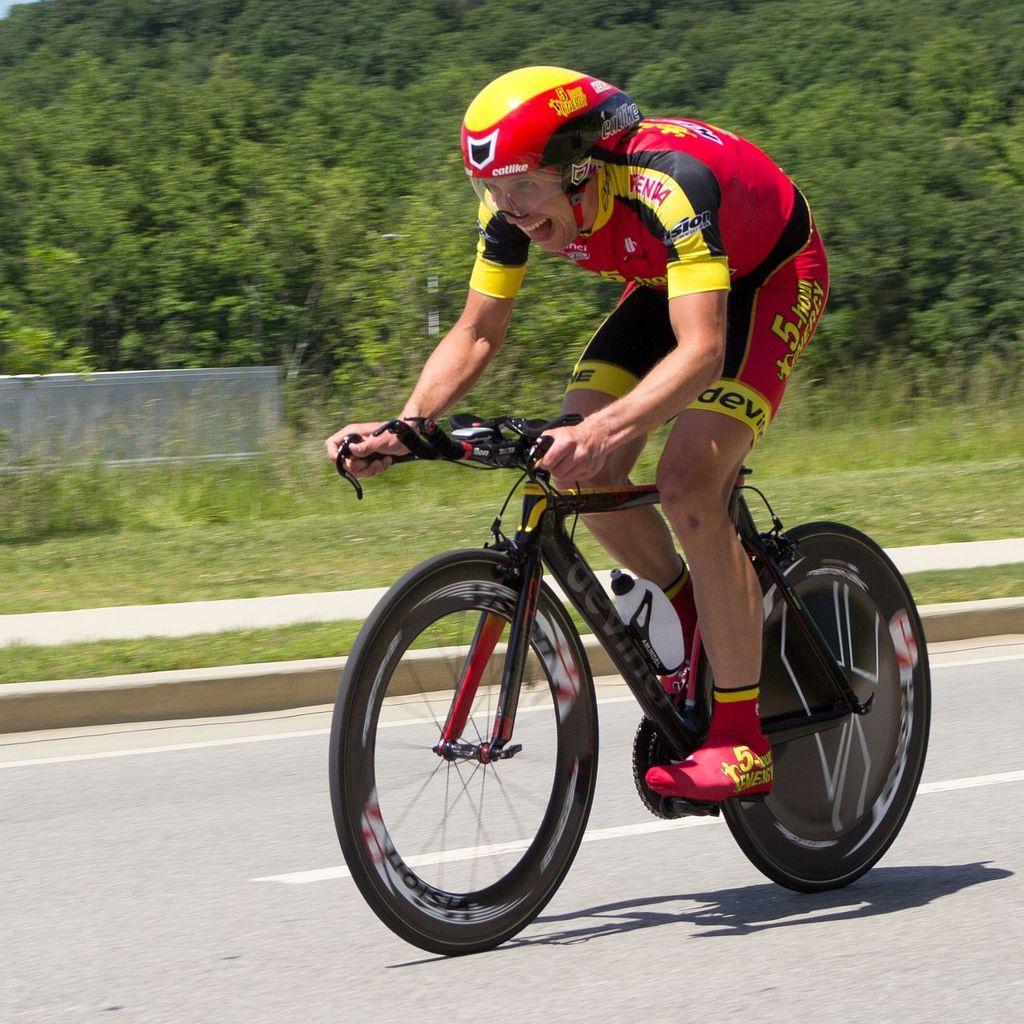How would you summarize this image in a sentence or two? In this image we can see a person is riding a bicycle, there are trees, there is a grass. 